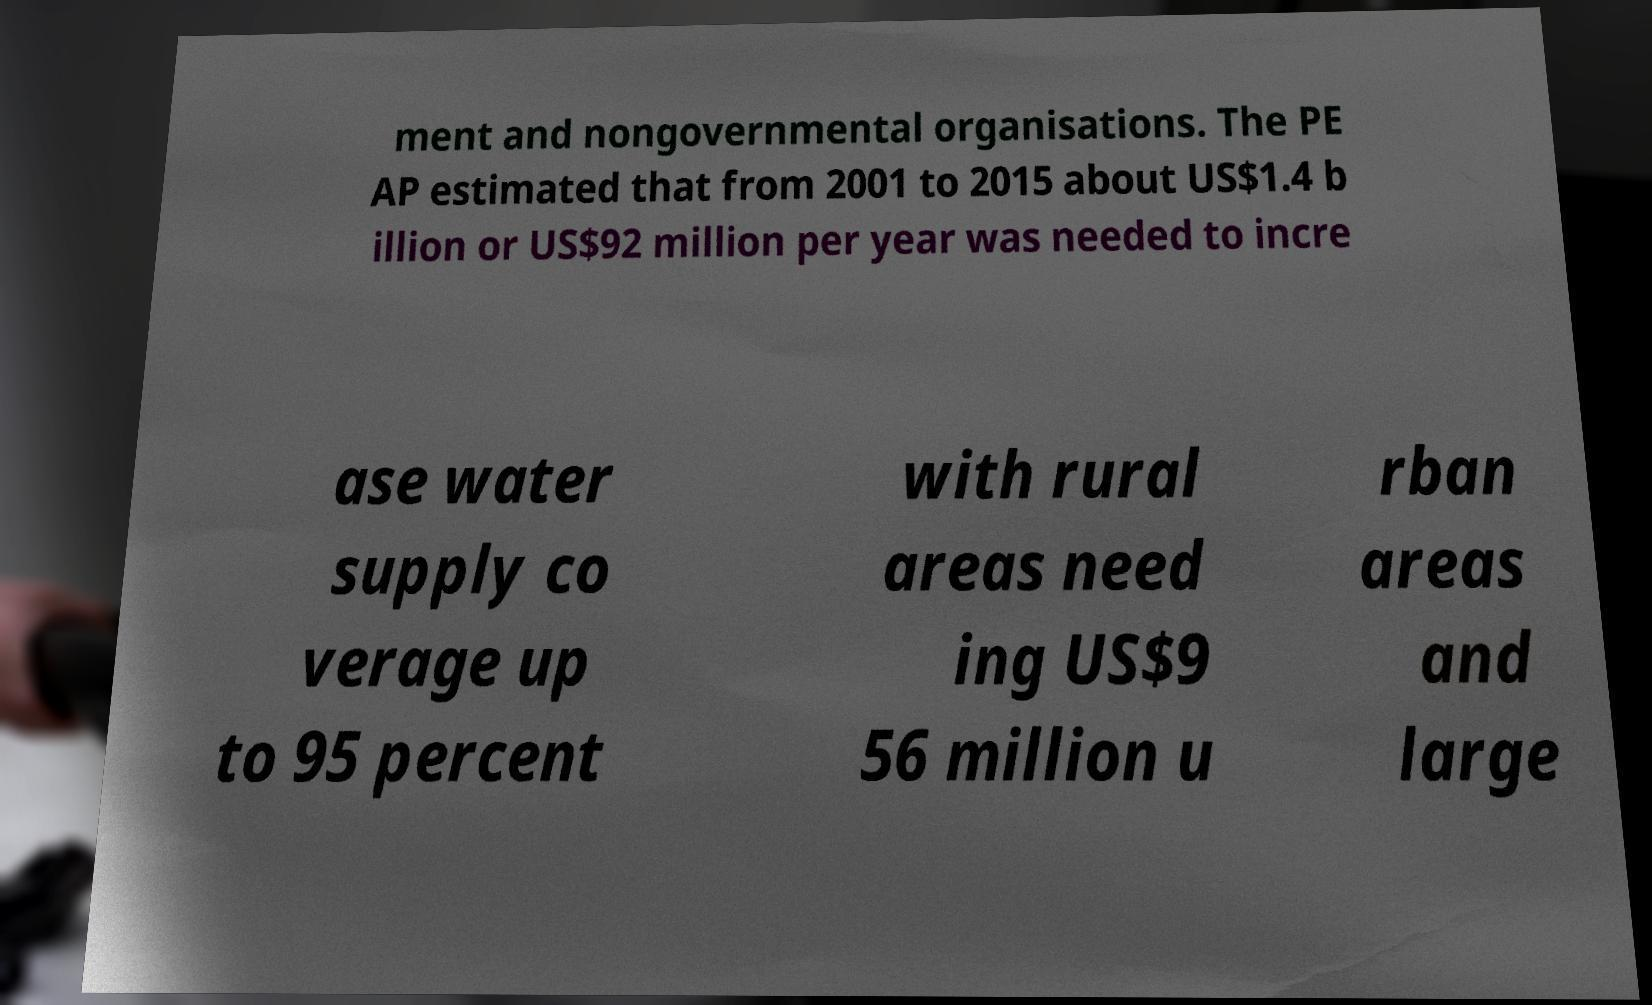Please read and relay the text visible in this image. What does it say? ment and nongovernmental organisations. The PE AP estimated that from 2001 to 2015 about US$1.4 b illion or US$92 million per year was needed to incre ase water supply co verage up to 95 percent with rural areas need ing US$9 56 million u rban areas and large 